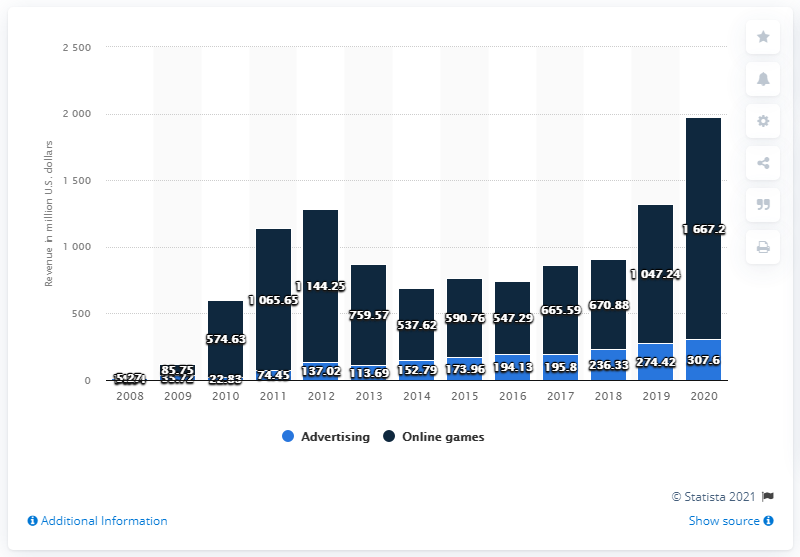List a handful of essential elements in this visual. In 2020, approximately 307.6% of Zynga's revenue was generated from advertising. In 2020, Zynga generated approximately $1667.2 million in revenue in the United States. 